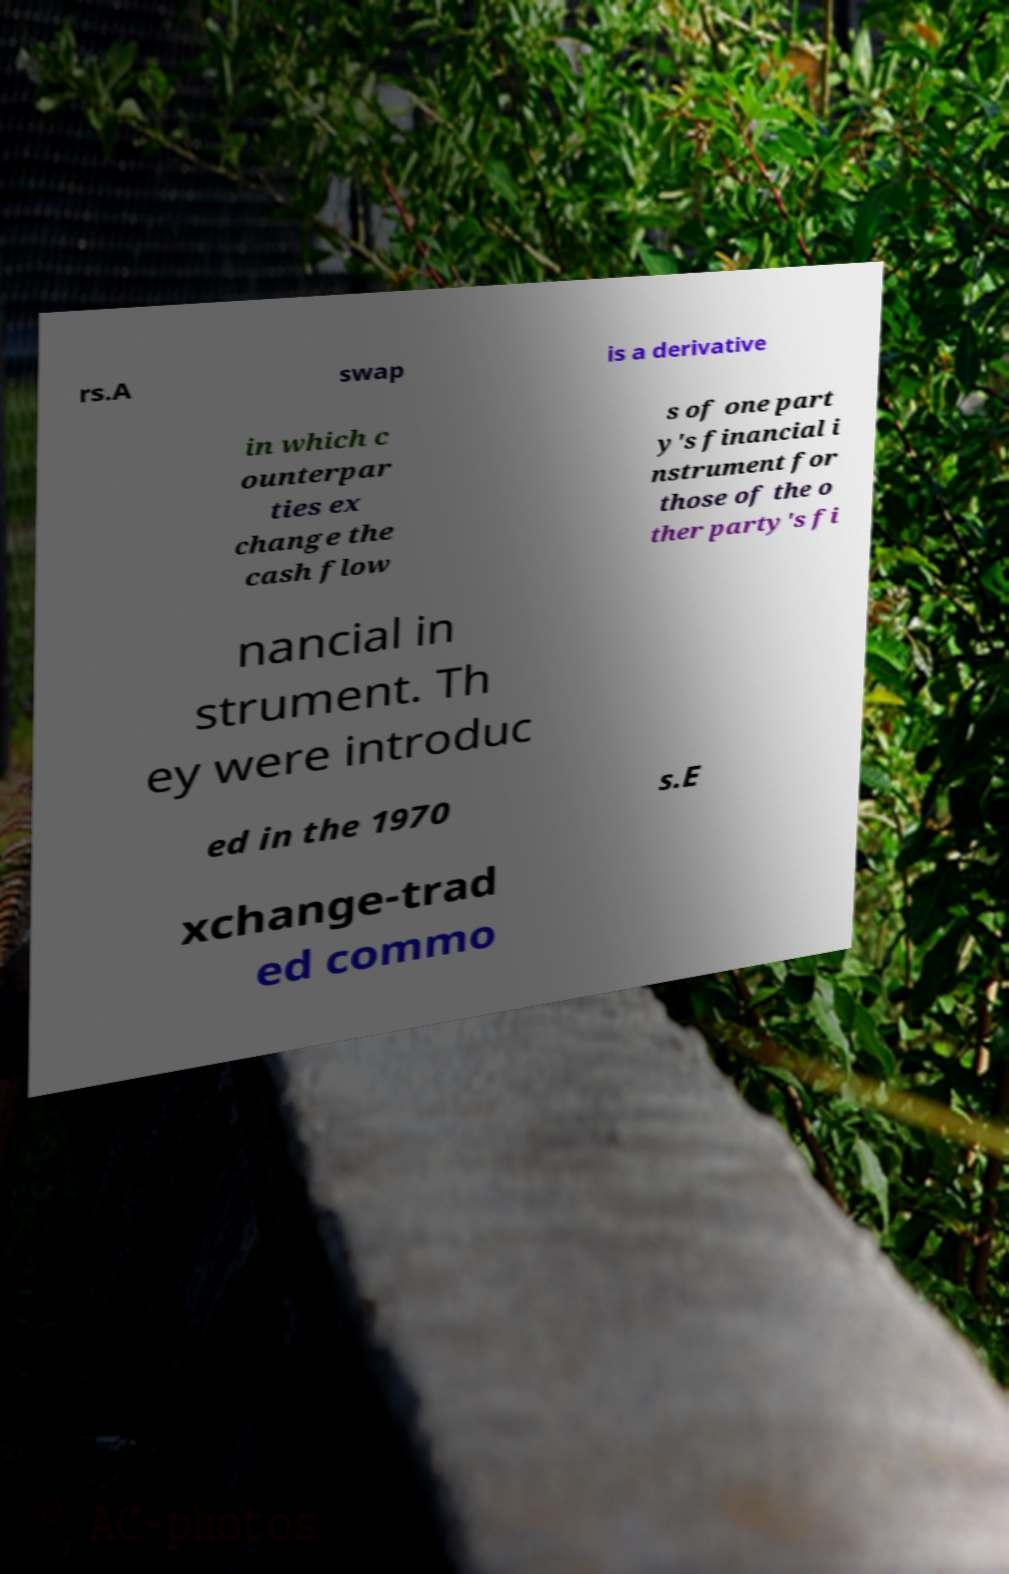What messages or text are displayed in this image? I need them in a readable, typed format. rs.A swap is a derivative in which c ounterpar ties ex change the cash flow s of one part y's financial i nstrument for those of the o ther party's fi nancial in strument. Th ey were introduc ed in the 1970 s.E xchange-trad ed commo 